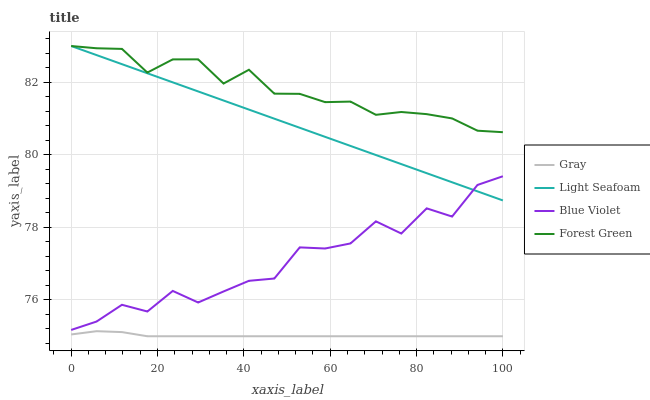Does Gray have the minimum area under the curve?
Answer yes or no. Yes. Does Forest Green have the maximum area under the curve?
Answer yes or no. Yes. Does Light Seafoam have the minimum area under the curve?
Answer yes or no. No. Does Light Seafoam have the maximum area under the curve?
Answer yes or no. No. Is Light Seafoam the smoothest?
Answer yes or no. Yes. Is Blue Violet the roughest?
Answer yes or no. Yes. Is Forest Green the smoothest?
Answer yes or no. No. Is Forest Green the roughest?
Answer yes or no. No. Does Gray have the lowest value?
Answer yes or no. Yes. Does Light Seafoam have the lowest value?
Answer yes or no. No. Does Light Seafoam have the highest value?
Answer yes or no. Yes. Does Blue Violet have the highest value?
Answer yes or no. No. Is Gray less than Light Seafoam?
Answer yes or no. Yes. Is Blue Violet greater than Gray?
Answer yes or no. Yes. Does Forest Green intersect Light Seafoam?
Answer yes or no. Yes. Is Forest Green less than Light Seafoam?
Answer yes or no. No. Is Forest Green greater than Light Seafoam?
Answer yes or no. No. Does Gray intersect Light Seafoam?
Answer yes or no. No. 